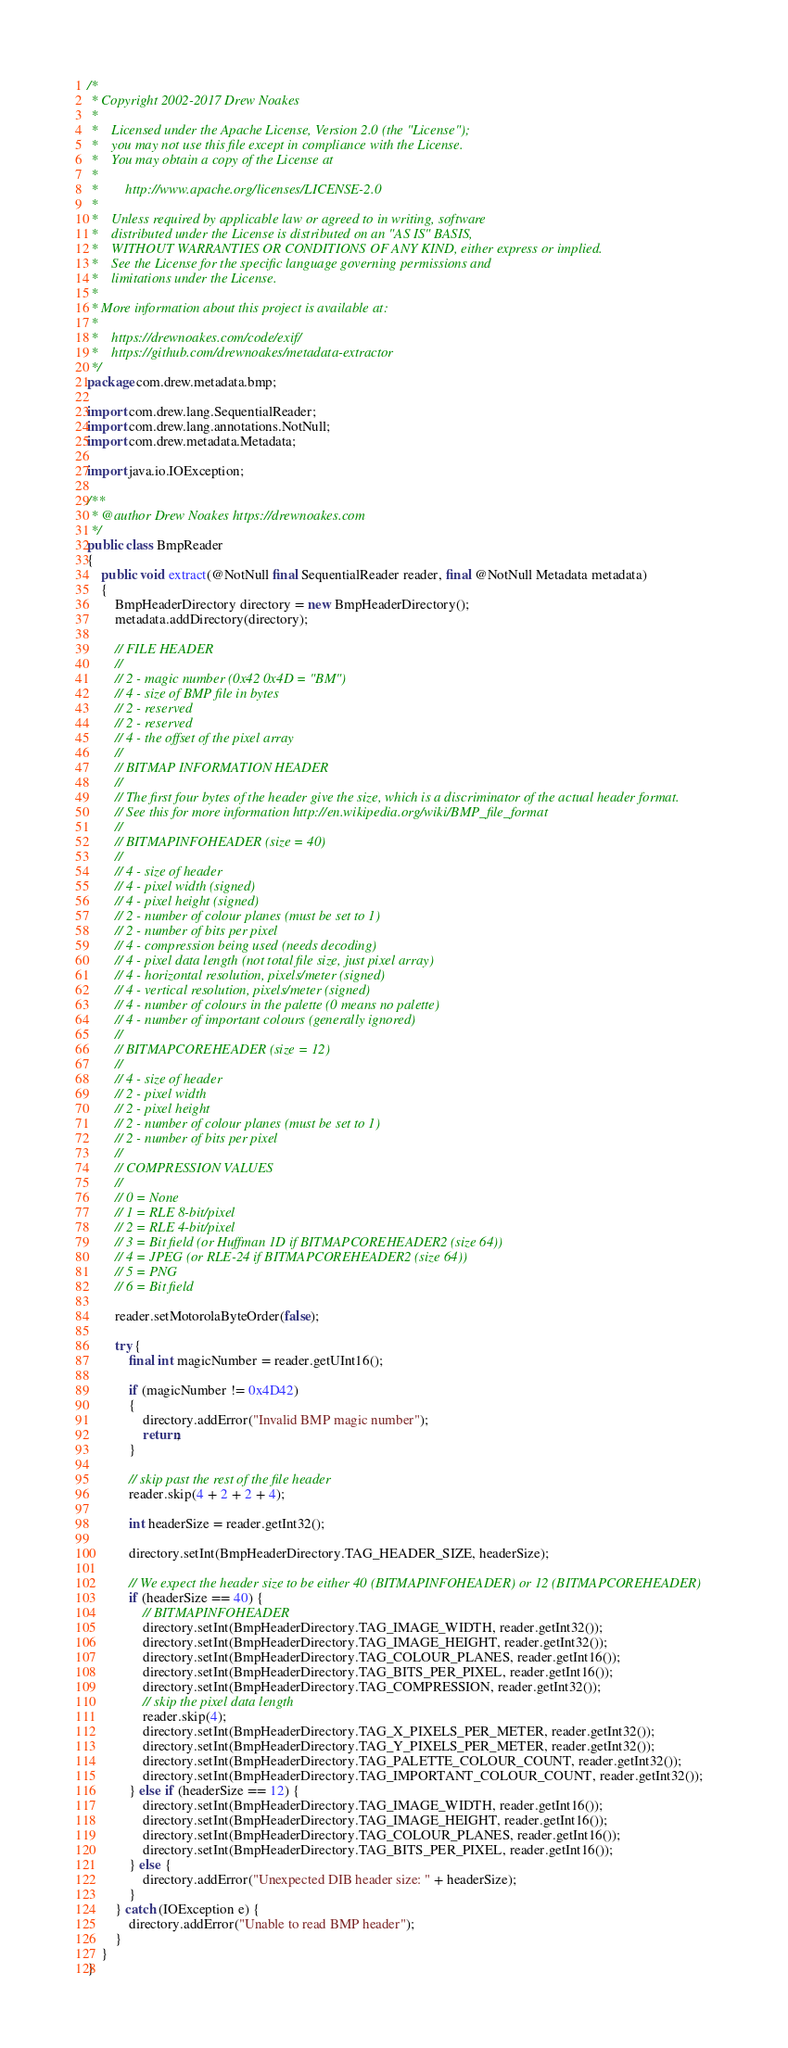<code> <loc_0><loc_0><loc_500><loc_500><_Java_>/*
 * Copyright 2002-2017 Drew Noakes
 *
 *    Licensed under the Apache License, Version 2.0 (the "License");
 *    you may not use this file except in compliance with the License.
 *    You may obtain a copy of the License at
 *
 *        http://www.apache.org/licenses/LICENSE-2.0
 *
 *    Unless required by applicable law or agreed to in writing, software
 *    distributed under the License is distributed on an "AS IS" BASIS,
 *    WITHOUT WARRANTIES OR CONDITIONS OF ANY KIND, either express or implied.
 *    See the License for the specific language governing permissions and
 *    limitations under the License.
 *
 * More information about this project is available at:
 *
 *    https://drewnoakes.com/code/exif/
 *    https://github.com/drewnoakes/metadata-extractor
 */
package com.drew.metadata.bmp;

import com.drew.lang.SequentialReader;
import com.drew.lang.annotations.NotNull;
import com.drew.metadata.Metadata;

import java.io.IOException;

/**
 * @author Drew Noakes https://drewnoakes.com
 */
public class BmpReader
{
    public void extract(@NotNull final SequentialReader reader, final @NotNull Metadata metadata)
    {
        BmpHeaderDirectory directory = new BmpHeaderDirectory();
        metadata.addDirectory(directory);

        // FILE HEADER
        //
        // 2 - magic number (0x42 0x4D = "BM")
        // 4 - size of BMP file in bytes
        // 2 - reserved
        // 2 - reserved
        // 4 - the offset of the pixel array
        //
        // BITMAP INFORMATION HEADER
        //
        // The first four bytes of the header give the size, which is a discriminator of the actual header format.
        // See this for more information http://en.wikipedia.org/wiki/BMP_file_format
        //
        // BITMAPINFOHEADER (size = 40)
        //
        // 4 - size of header
        // 4 - pixel width (signed)
        // 4 - pixel height (signed)
        // 2 - number of colour planes (must be set to 1)
        // 2 - number of bits per pixel
        // 4 - compression being used (needs decoding)
        // 4 - pixel data length (not total file size, just pixel array)
        // 4 - horizontal resolution, pixels/meter (signed)
        // 4 - vertical resolution, pixels/meter (signed)
        // 4 - number of colours in the palette (0 means no palette)
        // 4 - number of important colours (generally ignored)
        //
        // BITMAPCOREHEADER (size = 12)
        //
        // 4 - size of header
        // 2 - pixel width
        // 2 - pixel height
        // 2 - number of colour planes (must be set to 1)
        // 2 - number of bits per pixel
        //
        // COMPRESSION VALUES
        //
        // 0 = None
        // 1 = RLE 8-bit/pixel
        // 2 = RLE 4-bit/pixel
        // 3 = Bit field (or Huffman 1D if BITMAPCOREHEADER2 (size 64))
        // 4 = JPEG (or RLE-24 if BITMAPCOREHEADER2 (size 64))
        // 5 = PNG
        // 6 = Bit field

        reader.setMotorolaByteOrder(false);

        try {
            final int magicNumber = reader.getUInt16();

            if (magicNumber != 0x4D42)
            {
                directory.addError("Invalid BMP magic number");
                return;
            }

            // skip past the rest of the file header
            reader.skip(4 + 2 + 2 + 4);

            int headerSize = reader.getInt32();

            directory.setInt(BmpHeaderDirectory.TAG_HEADER_SIZE, headerSize);

            // We expect the header size to be either 40 (BITMAPINFOHEADER) or 12 (BITMAPCOREHEADER)
            if (headerSize == 40) {
                // BITMAPINFOHEADER
                directory.setInt(BmpHeaderDirectory.TAG_IMAGE_WIDTH, reader.getInt32());
                directory.setInt(BmpHeaderDirectory.TAG_IMAGE_HEIGHT, reader.getInt32());
                directory.setInt(BmpHeaderDirectory.TAG_COLOUR_PLANES, reader.getInt16());
                directory.setInt(BmpHeaderDirectory.TAG_BITS_PER_PIXEL, reader.getInt16());
                directory.setInt(BmpHeaderDirectory.TAG_COMPRESSION, reader.getInt32());
                // skip the pixel data length
                reader.skip(4);
                directory.setInt(BmpHeaderDirectory.TAG_X_PIXELS_PER_METER, reader.getInt32());
                directory.setInt(BmpHeaderDirectory.TAG_Y_PIXELS_PER_METER, reader.getInt32());
                directory.setInt(BmpHeaderDirectory.TAG_PALETTE_COLOUR_COUNT, reader.getInt32());
                directory.setInt(BmpHeaderDirectory.TAG_IMPORTANT_COLOUR_COUNT, reader.getInt32());
            } else if (headerSize == 12) {
                directory.setInt(BmpHeaderDirectory.TAG_IMAGE_WIDTH, reader.getInt16());
                directory.setInt(BmpHeaderDirectory.TAG_IMAGE_HEIGHT, reader.getInt16());
                directory.setInt(BmpHeaderDirectory.TAG_COLOUR_PLANES, reader.getInt16());
                directory.setInt(BmpHeaderDirectory.TAG_BITS_PER_PIXEL, reader.getInt16());
            } else {
                directory.addError("Unexpected DIB header size: " + headerSize);
            }
        } catch (IOException e) {
            directory.addError("Unable to read BMP header");
        }
    }
}
</code> 